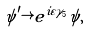<formula> <loc_0><loc_0><loc_500><loc_500>\psi ^ { \prime } \rightarrow e ^ { i \varepsilon \gamma _ { 5 } } \psi ,</formula> 